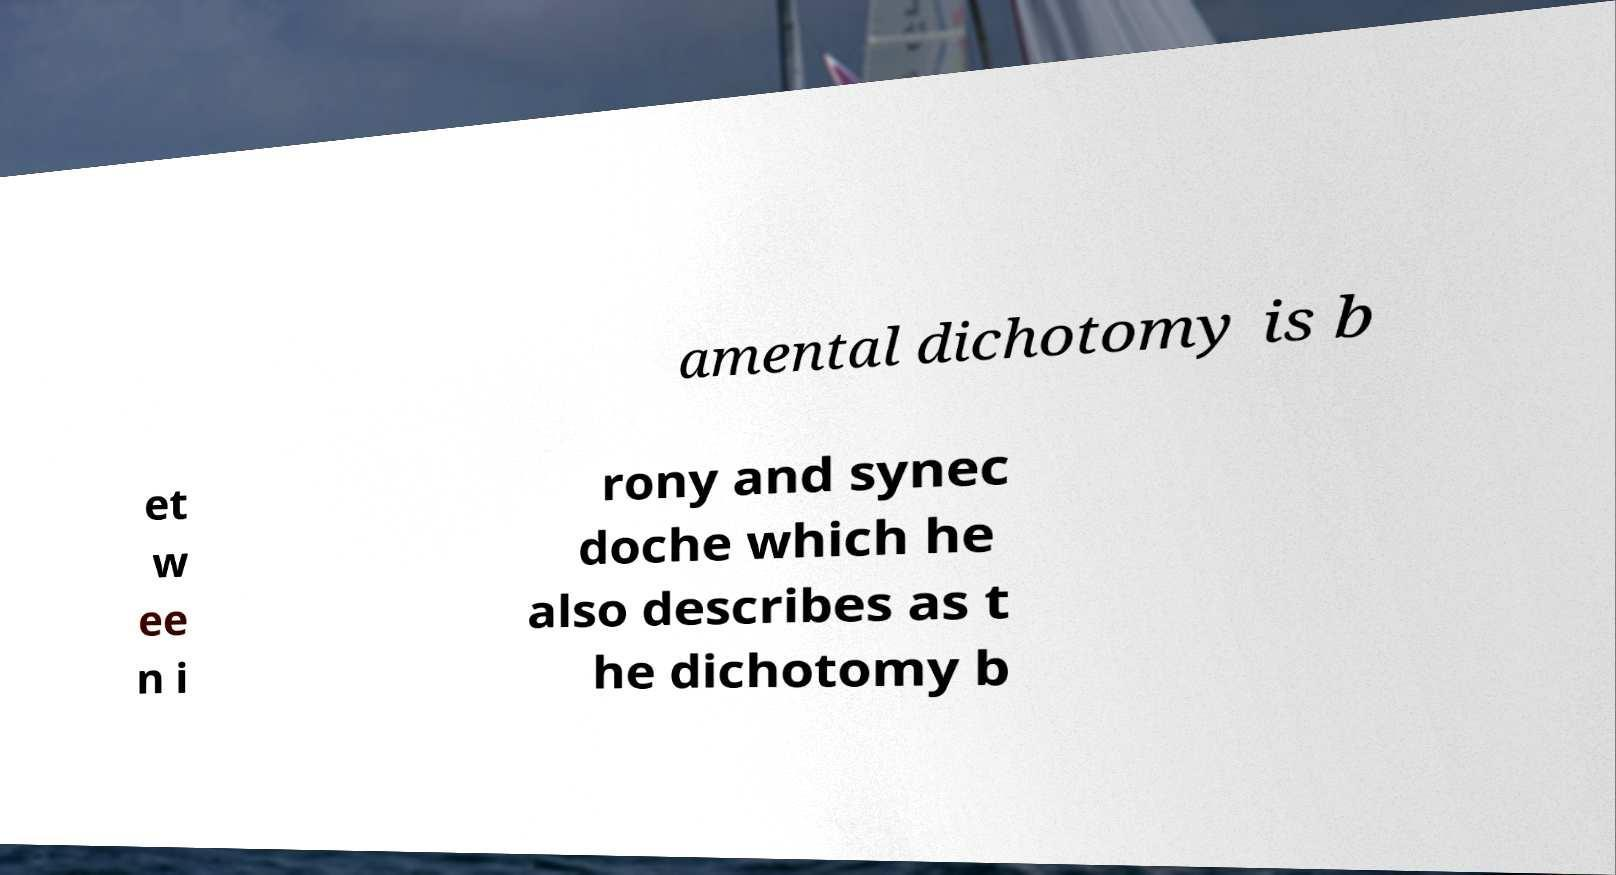For documentation purposes, I need the text within this image transcribed. Could you provide that? amental dichotomy is b et w ee n i rony and synec doche which he also describes as t he dichotomy b 